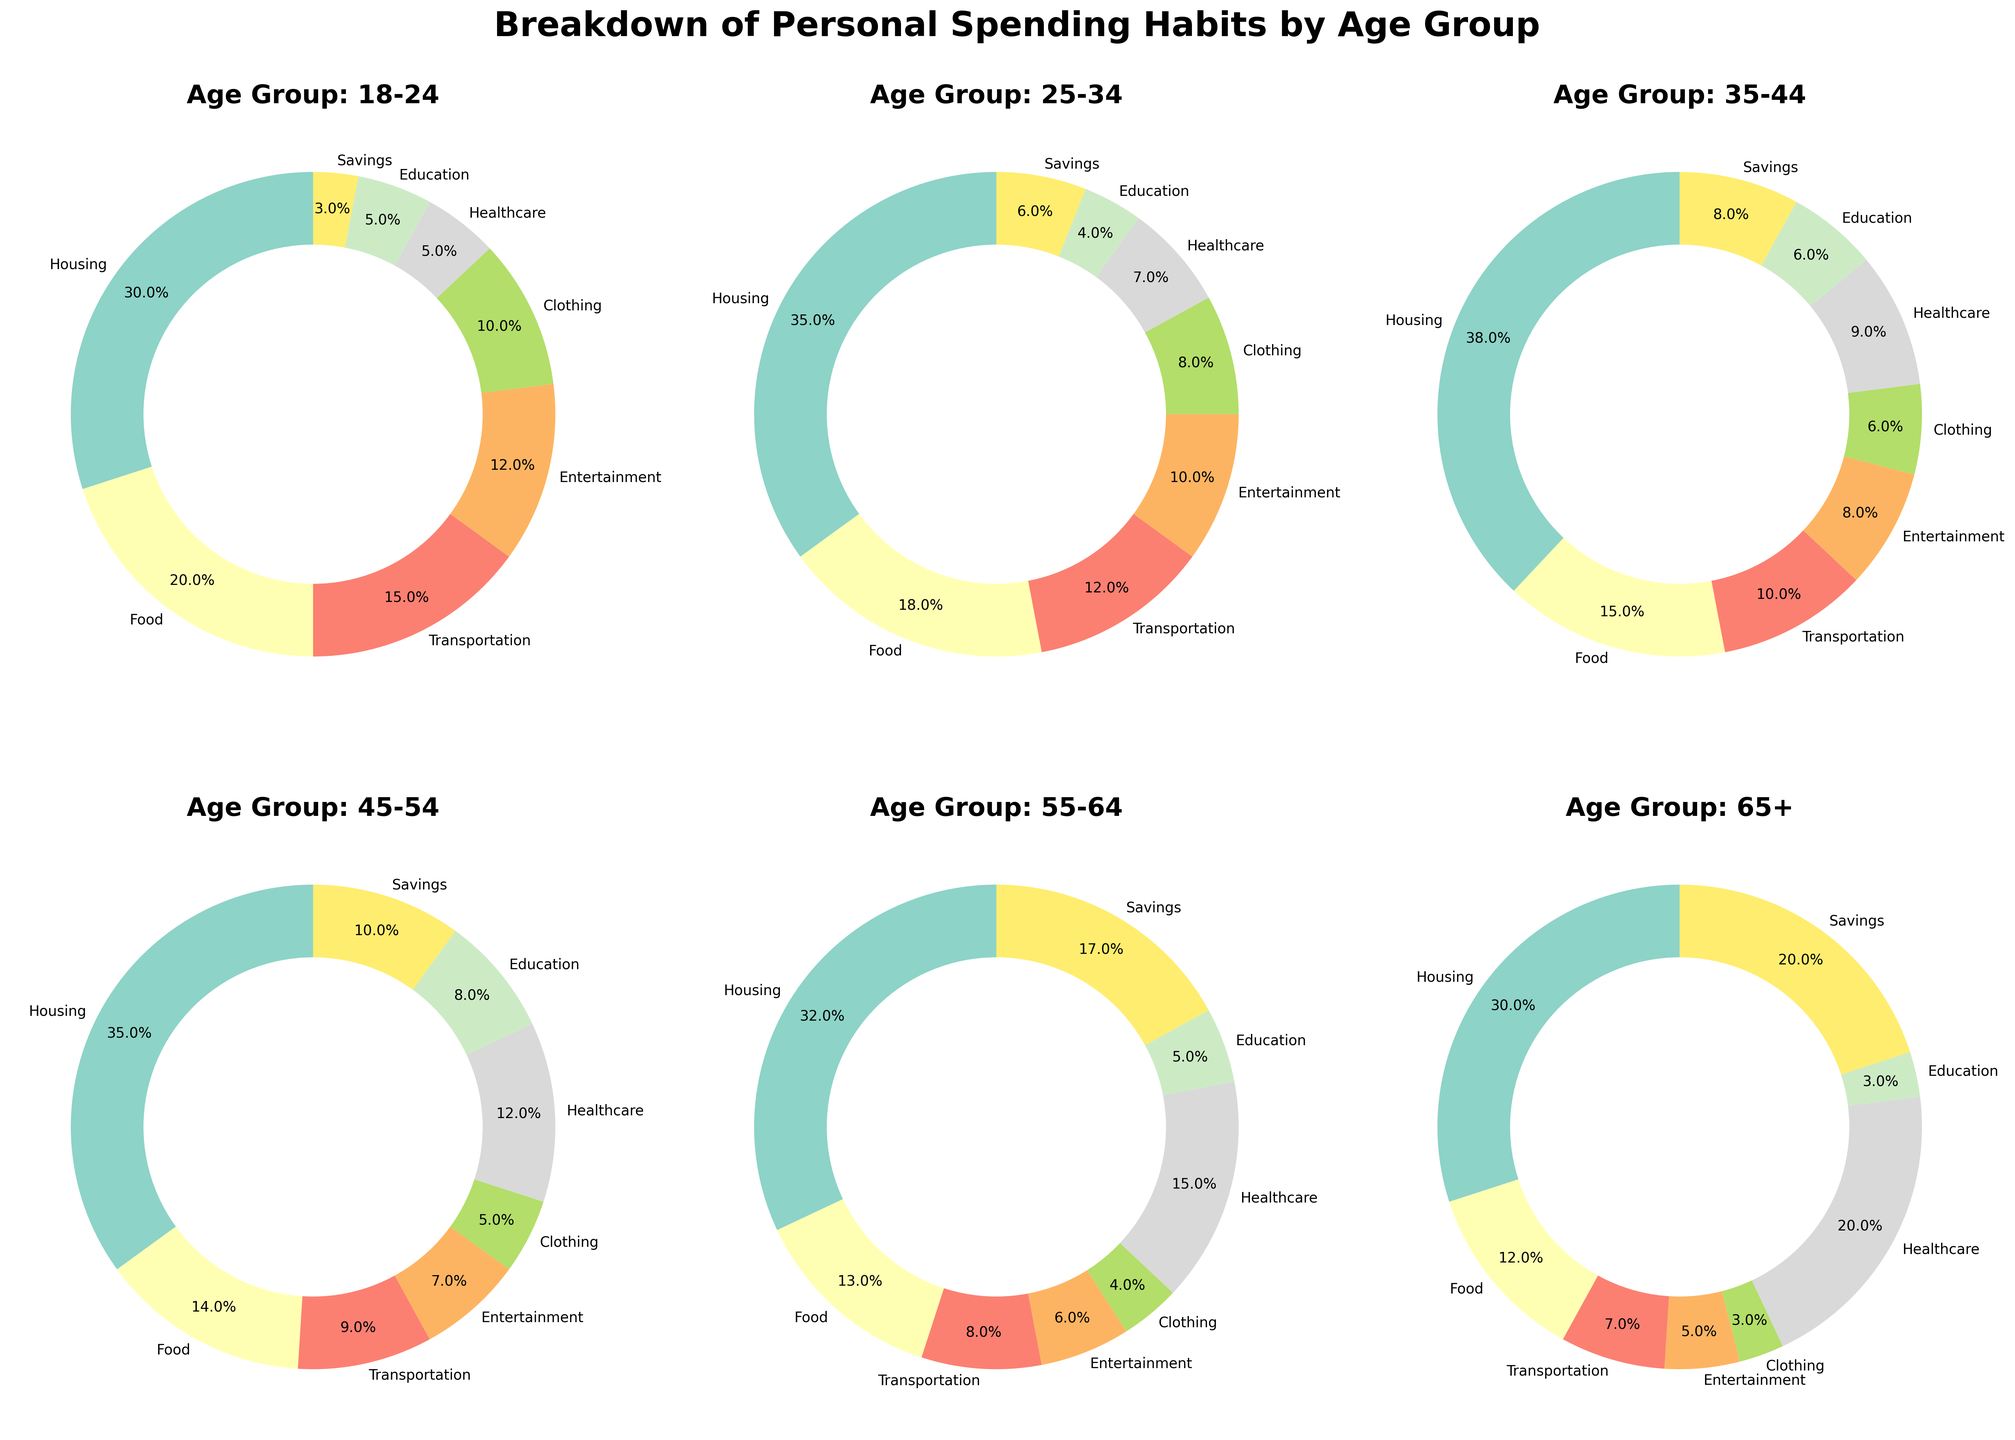Which age group spends the most on healthcare? To identify which age group spends the most on healthcare, we refer to the corresponding section of the pie charts for each age group. The largest percentage for healthcare is seen in the age group 65+ with 20%.
Answer: 65+ Which category sees the smallest percentage of spending for the age group 18-24? By looking at the pie chart for the age group 18-24, we can see that both Education and Savings have the smallest percentage, each with 5%.
Answer: Education and Savings How much more does the age group 35-44 spend on housing compared to the age group 18-24? First, find the percentage spent on housing in both age groups. For 35-44, it is 38%, and for 18-24, it is 30%. Subtracting these gives 38% - 30% = 8%.
Answer: 8% Which age group spends more on food as a percentage of their overall spending, the age group 25-34 or the age group 45-54? Checking the pie charts, the age group 25-34 spends 18% on food, while the age group 45-54 spends 14% on food. Therefore, the age group 25-34 spends more.
Answer: Age Group 25-34 What is the combined percentage spent on entertainment and healthcare for the age group 55-64? According to the pie chart, the 55-64 age group spends 6% on entertainment and 15% on healthcare. Adding these two percentages gives 6% + 15% = 21%.
Answer: 21% How does the spending percentage on savings for the age group 45-54 compare with the savings for the age group 65+? The 45-54 age group spends 10% on savings, while the 65+ age group spends 20% on savings. Comparing these, 65+ spends 10% more on savings than 45-54.
Answer: 10% more Which category does the age group 25-34 spend the least on and what is the percentage? Looking at the pie chart for the age group 25-34, Education has the smallest percentage with 4%.
Answer: Education, 4% What are the top two spending categories for the age group 35-44? By checking the proportions in the pie chart for 35-44, Housing is the top spending category with 38%, followed by Food with 15%.
Answer: Housing and Food How much total percentage is spent on non-housing categories for the age group 18-24? The percentage spent on housing for the age group 18-24 is 30%. To find the total for non-housing categories, subtract housing from 100%: 100% - 30% = 70%.
Answer: 70% In which category does the age group 55-64 spend a larger percentage than the age group 25-34? Comparing the categories' percentages, the 55-64 group spends more on Healthcare (15% vs 7%) and Savings (17% vs 6%) compared to the 25-34 age group.
Answer: Healthcare and Savings 